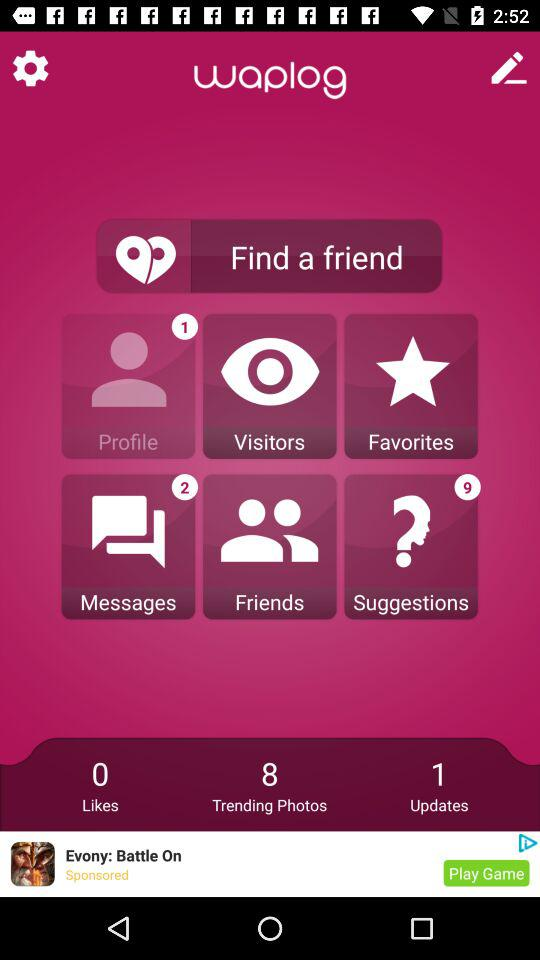How many updates are available in "waplog"? There is 1 update available in "waplog". 